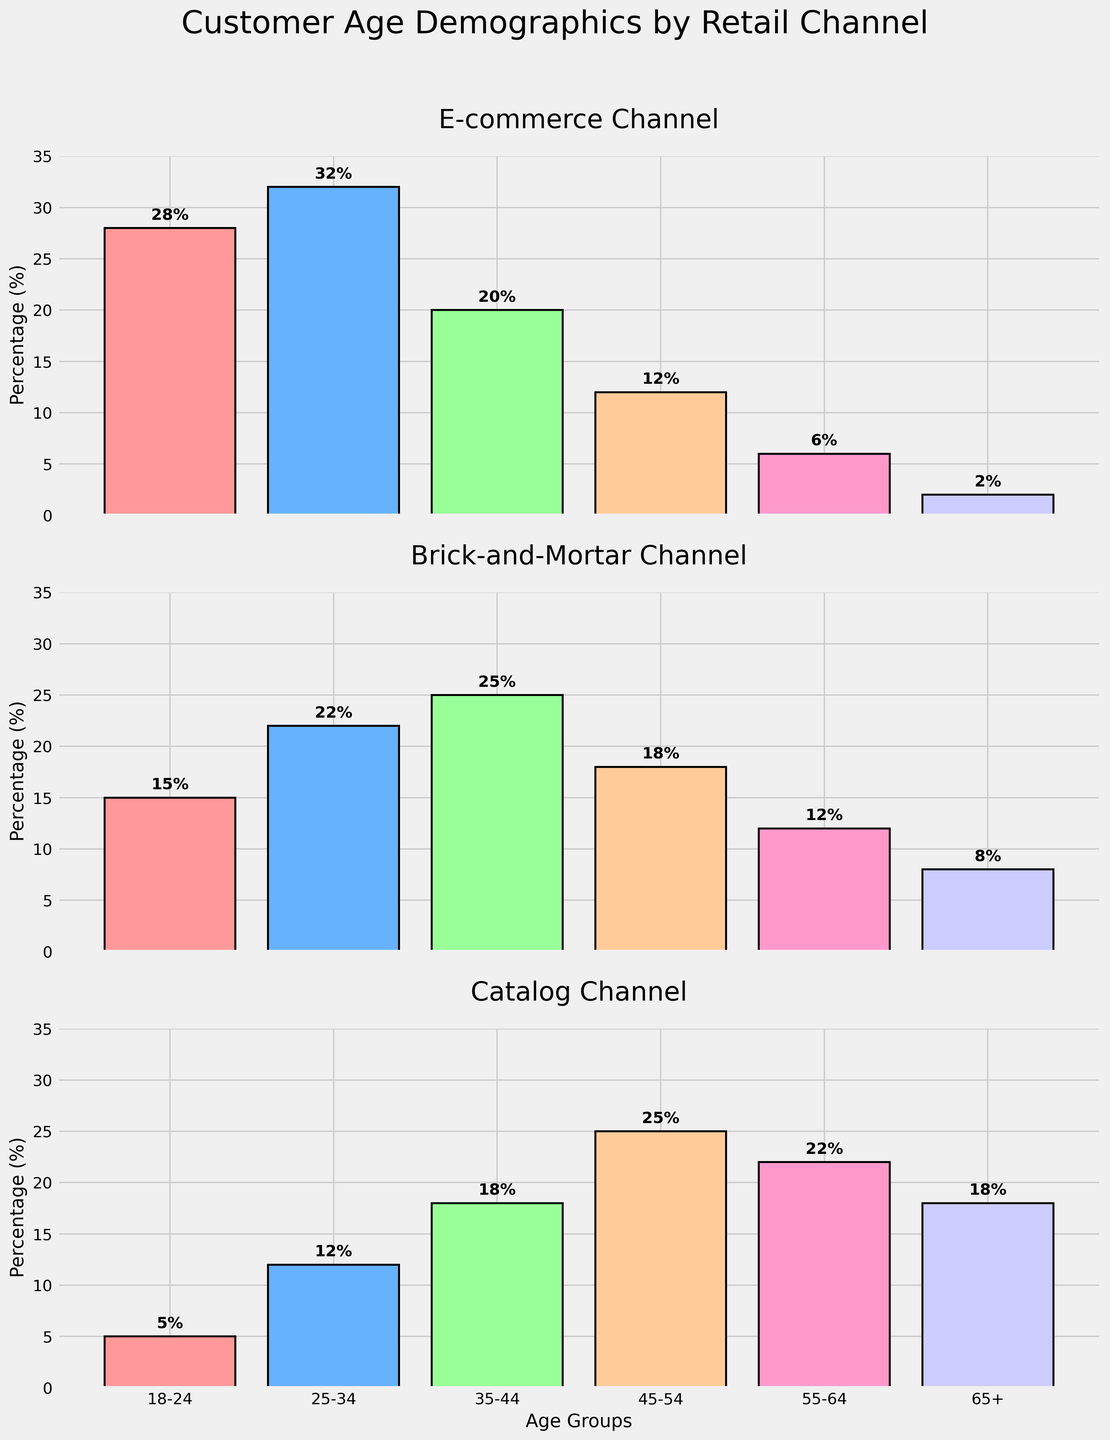What is the title of the chart? The title is usually found at the top of the chart. In this case, the title is placed above the vertical subplots.
Answer: Customer Age Demographics by Retail Channel Which age group has the highest percentage in the e-commerce channel? Look at the bar corresponding to the e-commerce channel subplot and identify the age group with the highest bar.
Answer: 25-34 What is the difference between the 18-24 age group in e-commerce and brick-and-mortar channels? Subtract the value of the 18-24 age group in the brick-and-mortar channel from that in the e-commerce channel (28 - 15).
Answer: 13 In which channel does the 55-64 age group have the highest percentage? Compare the bars of the 55-64 age group across all three channels and identify the highest one.
Answer: Catalog Which age group has the least percentage in the catalog channel? Locate the age group with the shortest bar in the catalog channel subplot.
Answer: 18-24 What is the average percentage of the 35-44 age group across all channels? Sum up the percentages of the 35-44 age group across all three channels (20 + 25 + 18) and divide by 3 to find the average.
Answer: 21 How many age groups does each subplot have? Count the number of bars for any channel subplot.
Answer: 6 Is the trend of increasing age group percentage consistent across all channels? Observe the direction of the bars from left to right for each channel. If they are all increasing, the trend is consistent. However, this consistency is only present in the catalog channel, while other channels show varying trends.
Answer: No Which channel has a higher percentage of the 65+ age group, e-commerce or brick-and-mortar? Compare the heights of the 65+ age group bars in the e-commerce and brick-and-mortar channel subplots.
Answer: Brick-and-Mortar 